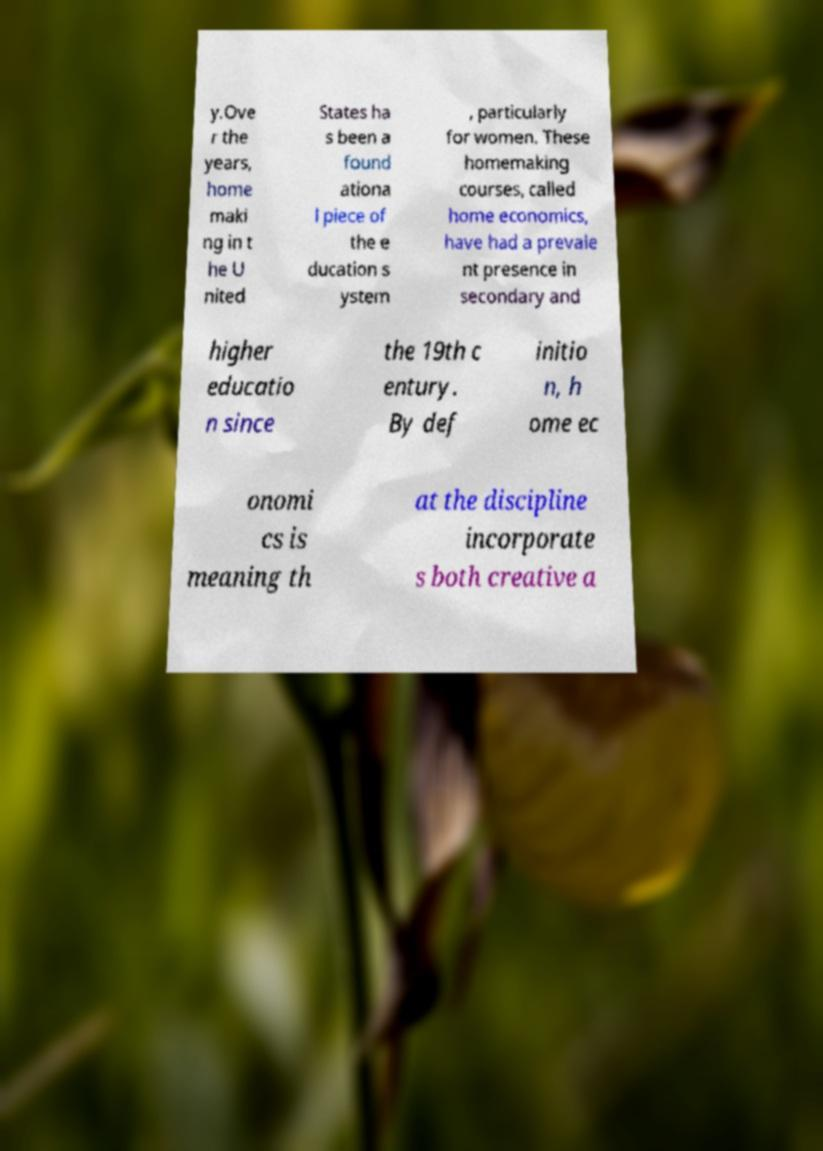What messages or text are displayed in this image? I need them in a readable, typed format. y.Ove r the years, home maki ng in t he U nited States ha s been a found ationa l piece of the e ducation s ystem , particularly for women. These homemaking courses, called home economics, have had a prevale nt presence in secondary and higher educatio n since the 19th c entury. By def initio n, h ome ec onomi cs is meaning th at the discipline incorporate s both creative a 